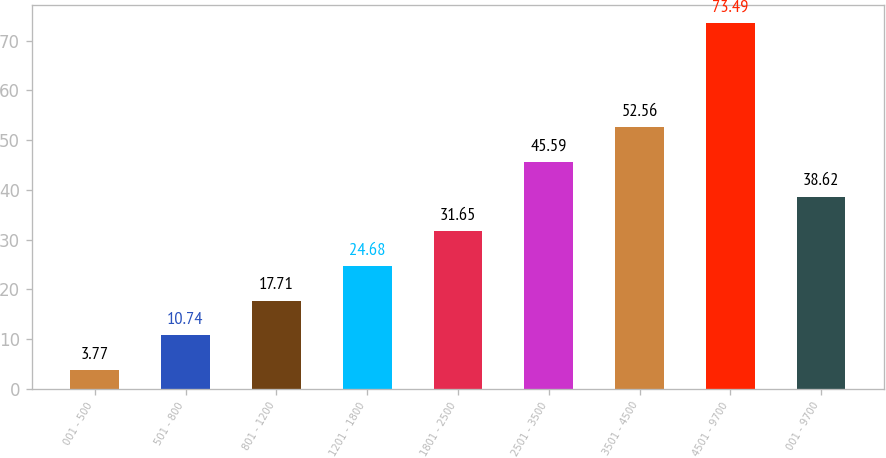<chart> <loc_0><loc_0><loc_500><loc_500><bar_chart><fcel>001 - 500<fcel>501 - 800<fcel>801 - 1200<fcel>1201 - 1800<fcel>1801 - 2500<fcel>2501 - 3500<fcel>3501 - 4500<fcel>4501 - 9700<fcel>001 - 9700<nl><fcel>3.77<fcel>10.74<fcel>17.71<fcel>24.68<fcel>31.65<fcel>45.59<fcel>52.56<fcel>73.49<fcel>38.62<nl></chart> 